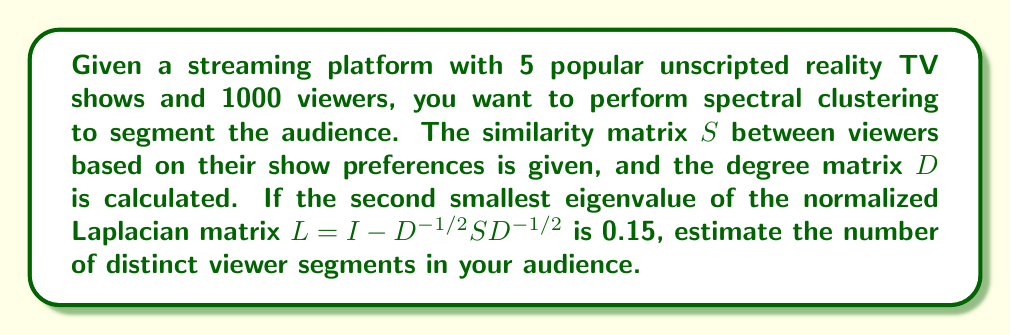Provide a solution to this math problem. To solve this problem, we'll follow these steps:

1) Recall that in spectral clustering, the number of clusters is typically determined by the eigengap heuristic. This involves looking at the difference between consecutive eigenvalues of the normalized Laplacian matrix.

2) The normalized Laplacian matrix is given by $L = I - D^{-1/2}SD^{-1/2}$, where $I$ is the identity matrix, $D$ is the degree matrix, and $S$ is the similarity matrix.

3) The eigenvalues of $L$ are always in the range $[0, 2]$. The number of eigenvalues equal to 0 corresponds to the number of connected components in the graph.

4) In this case, we're given that the second smallest eigenvalue is 0.15. This suggests that the smallest eigenvalue is likely 0, corresponding to one connected component (which is expected for a similarity graph).

5) A significant eigengap after the $k$-th eigenvalue suggests $k$ clusters. Here, we see a gap of 0.15 between the first (0) and second (0.15) eigenvalues.

6) This gap is considered significant in spectral clustering. Typically, eigenvalues below 0.1 or 0.2 are considered "small" and indicative of cluster structure.

7) Therefore, the eigengap heuristic suggests that there are 2 distinct viewer segments in the audience.

This aligns with common practice in unscripted reality TV, where audiences often segment into two main groups: passionate fans and casual viewers.
Answer: 2 viewer segments 